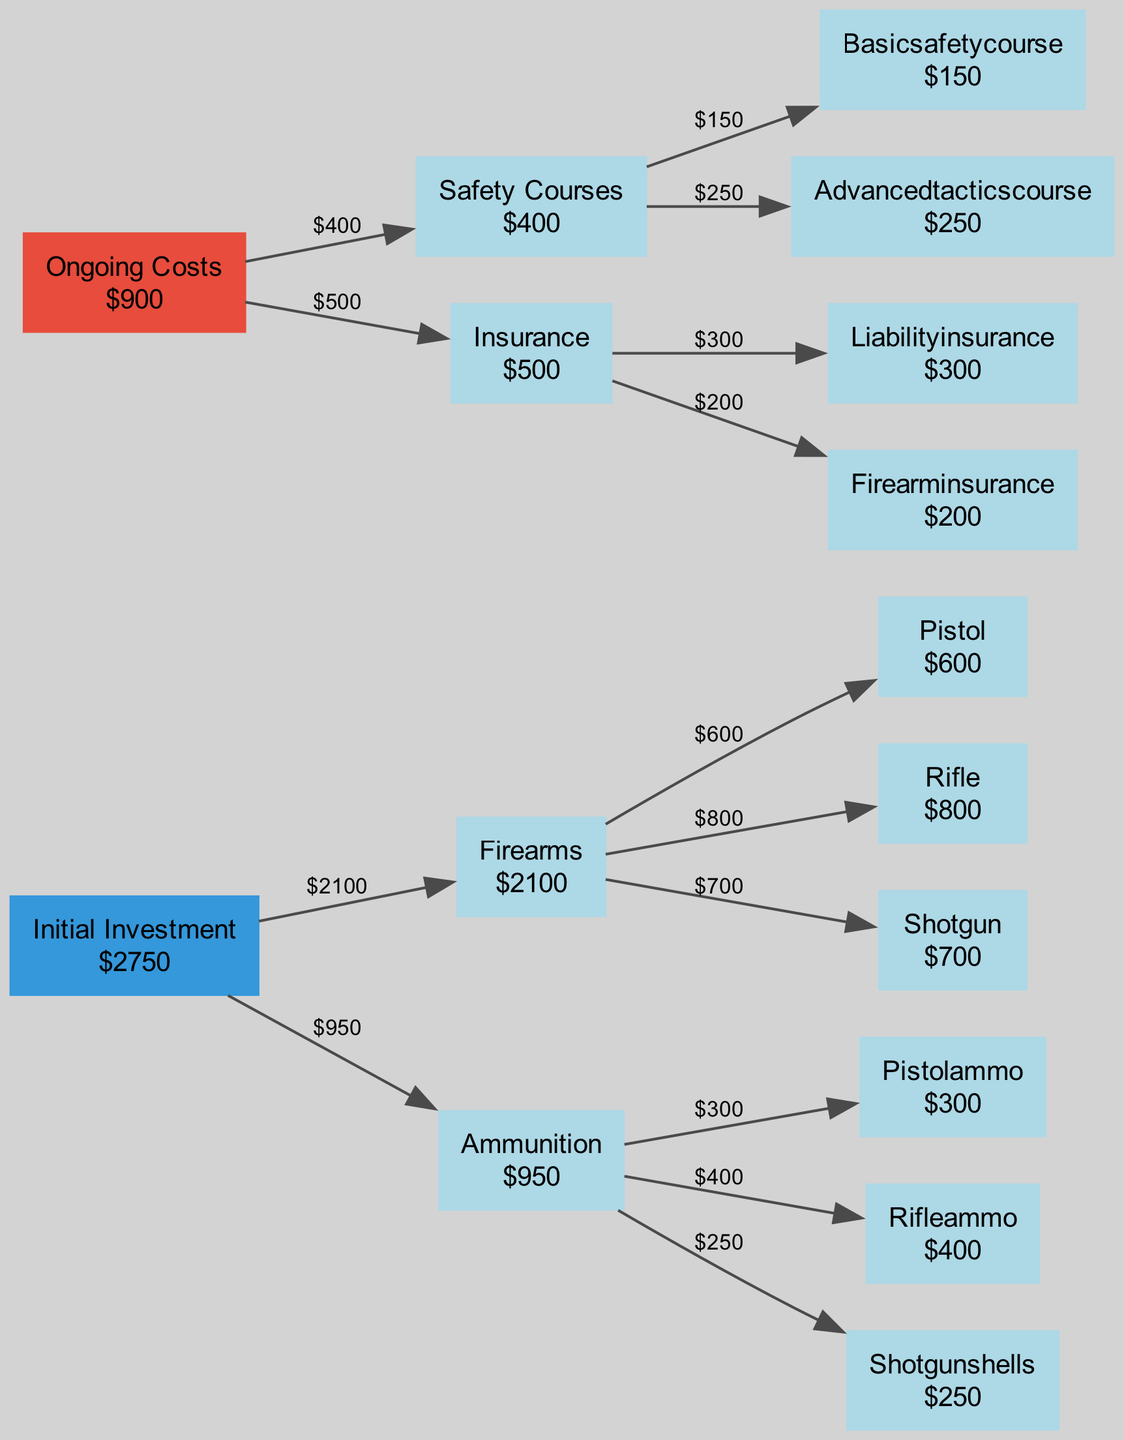What is the total initial investment cost? To find the total initial investment cost, first, add the costs of all items listed under initial investment, which includes firearms and ammunition. The firearms total is $600 + $800 + $700 = $2100, and the ammunition total is $300 + $400 + $250 = $950. Adding both totals gives $2100 + $950 = $3050.
Answer: $3050 How much does a basic safety course cost? The diagram specifies that the cost for a basic safety course is listed under safety courses. It shows that the basic safety course costs $150.
Answer: $150 What is the total ongoing cost? To determine the total ongoing cost, we need to sum the costs of all items under ongoing costs, which includes safety courses and insurance. The total for safety courses is $150 + $250 = $400, and the insurance total is $300 + $200 = $500. Adding these gives $400 + $500 = $900.
Answer: $900 Which firearm type has the highest cost? The diagram indicates the cost for each type of firearm. Adding them up, we see the pistol costs $600, the rifle costs $800, and the shotgun costs $700. The rifle, at $800, is the highest amount among these.
Answer: Rifle What is the total cost for insurance? The total cost for insurance is found by adding the costs associated with insurance listed in the diagram, which are $300 for liability insurance and $200 for firearm insurance. Thus, $300 + $200 = $500.
Answer: $500 How many individual courses are shown in the diagram? The diagram has listed two individual courses under safety courses: the basic safety course and the advanced tactics course. Therefore, the count of individual courses is two.
Answer: 2 What percentage of the total initial investment is spent on ammunition? To find the percentage spent on ammunition, first calculate the total initial investment which is $3050. The cost of ammunition is $950. The percentage is calculated as ($950 / $3050) * 100, which gives approximately 31.15%.
Answer: 31.15% Which category has the highest initial investment cost? To find which category has the highest initial investment cost, compare the totals for firearms ($2100) and ammunition ($950). The firearms category has the highest total at $2100.
Answer: Firearms 